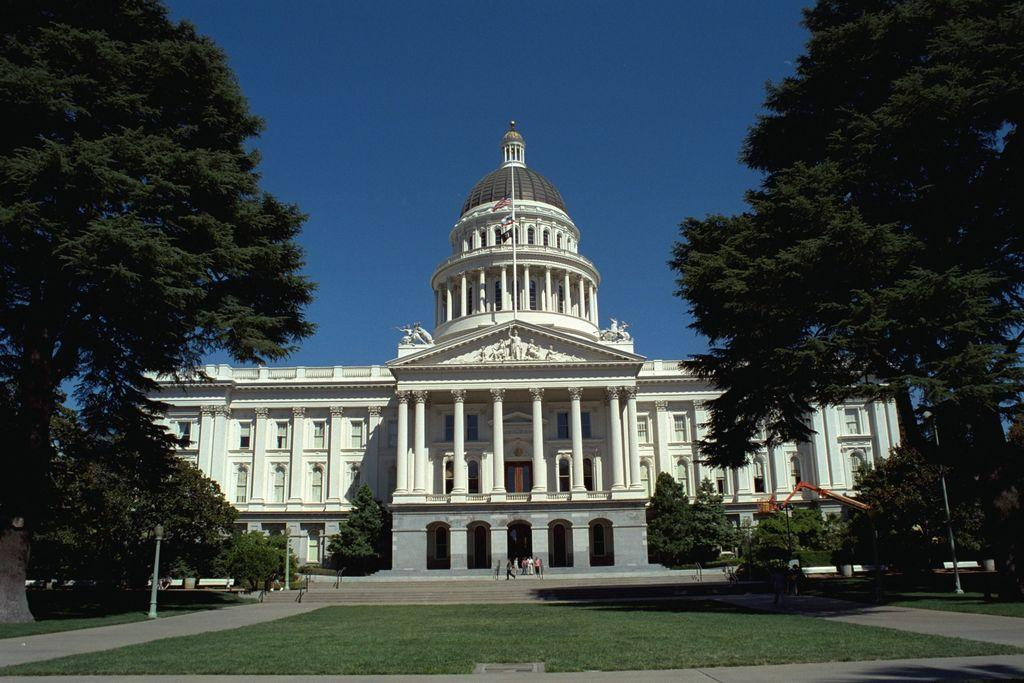What type of vegetation is present in the image? There is grass in the image. Can you describe the people in the image? There is a group of people in the image. What other natural elements can be seen in the image? There are trees in the image. What structures are present in the image? There are poles and a building in the image. What additional features are visible in the image? There are lights in the image. What can be seen in the background of the image? The sky is visible in the background of the image. What type of string is being used to hold the worm in the image? There is no string or worm present in the image. What color is the coat worn by the person in the image? There are no coats or people wearing coats in the image. 